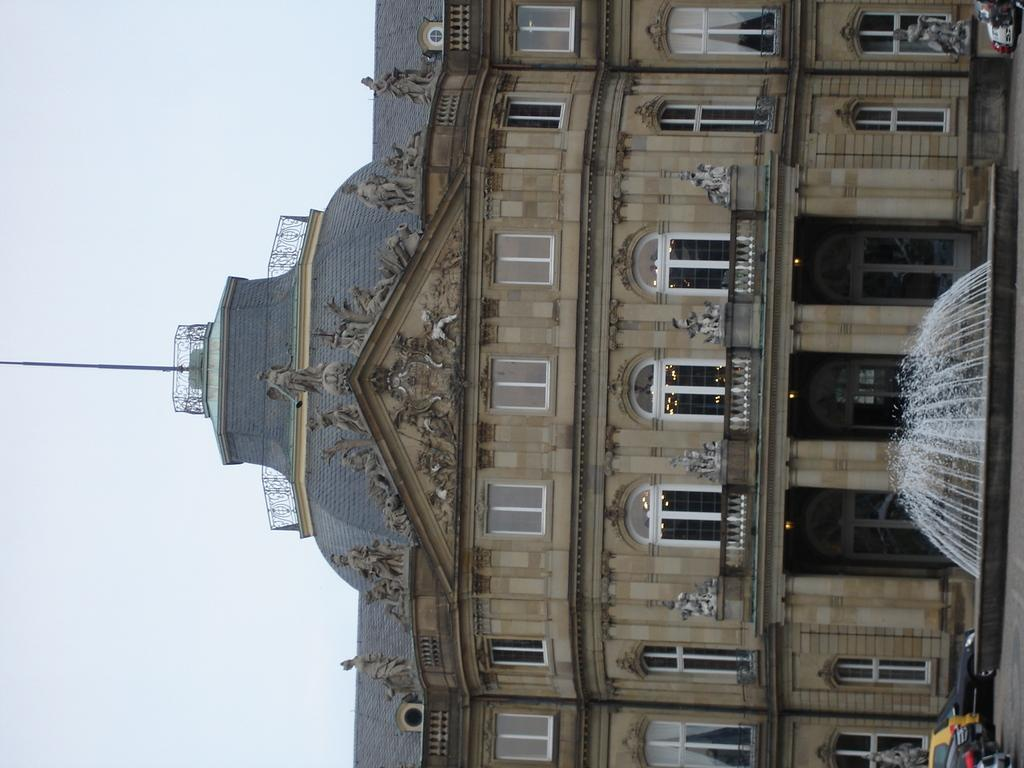What structure is located on the right side of the image? There is a building on the right side of the image. What feature can be seen on the building? The building has windows. What is in front of the building? There is a fountain in front of the building. What else can be seen in front of the building? There are cars in front of the building. What type of disease is affecting the building in the image? There is no indication of any disease affecting the building in the image. How many pies are visible on the windows of the building? There are no pies visible on the windows of the building; only windows are present. 